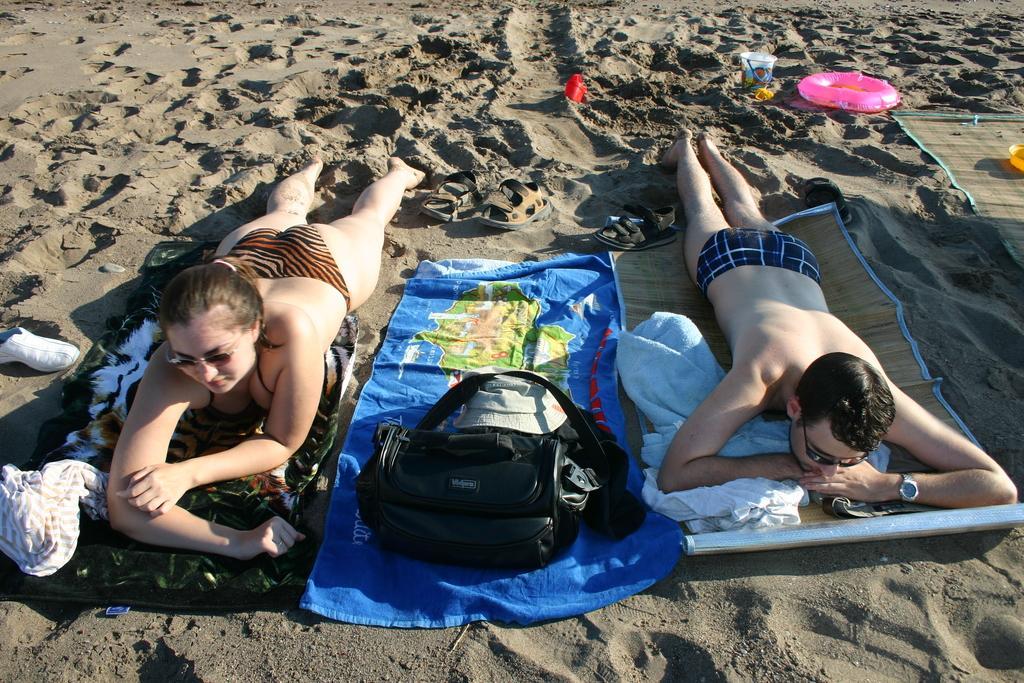Describe this image in one or two sentences. In this image there are two people lying on the mats on the beach sand, around them there are bags, shoes, clothes and some other objects. 